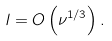Convert formula to latex. <formula><loc_0><loc_0><loc_500><loc_500>l = O \left ( \nu ^ { 1 / 3 } \right ) .</formula> 